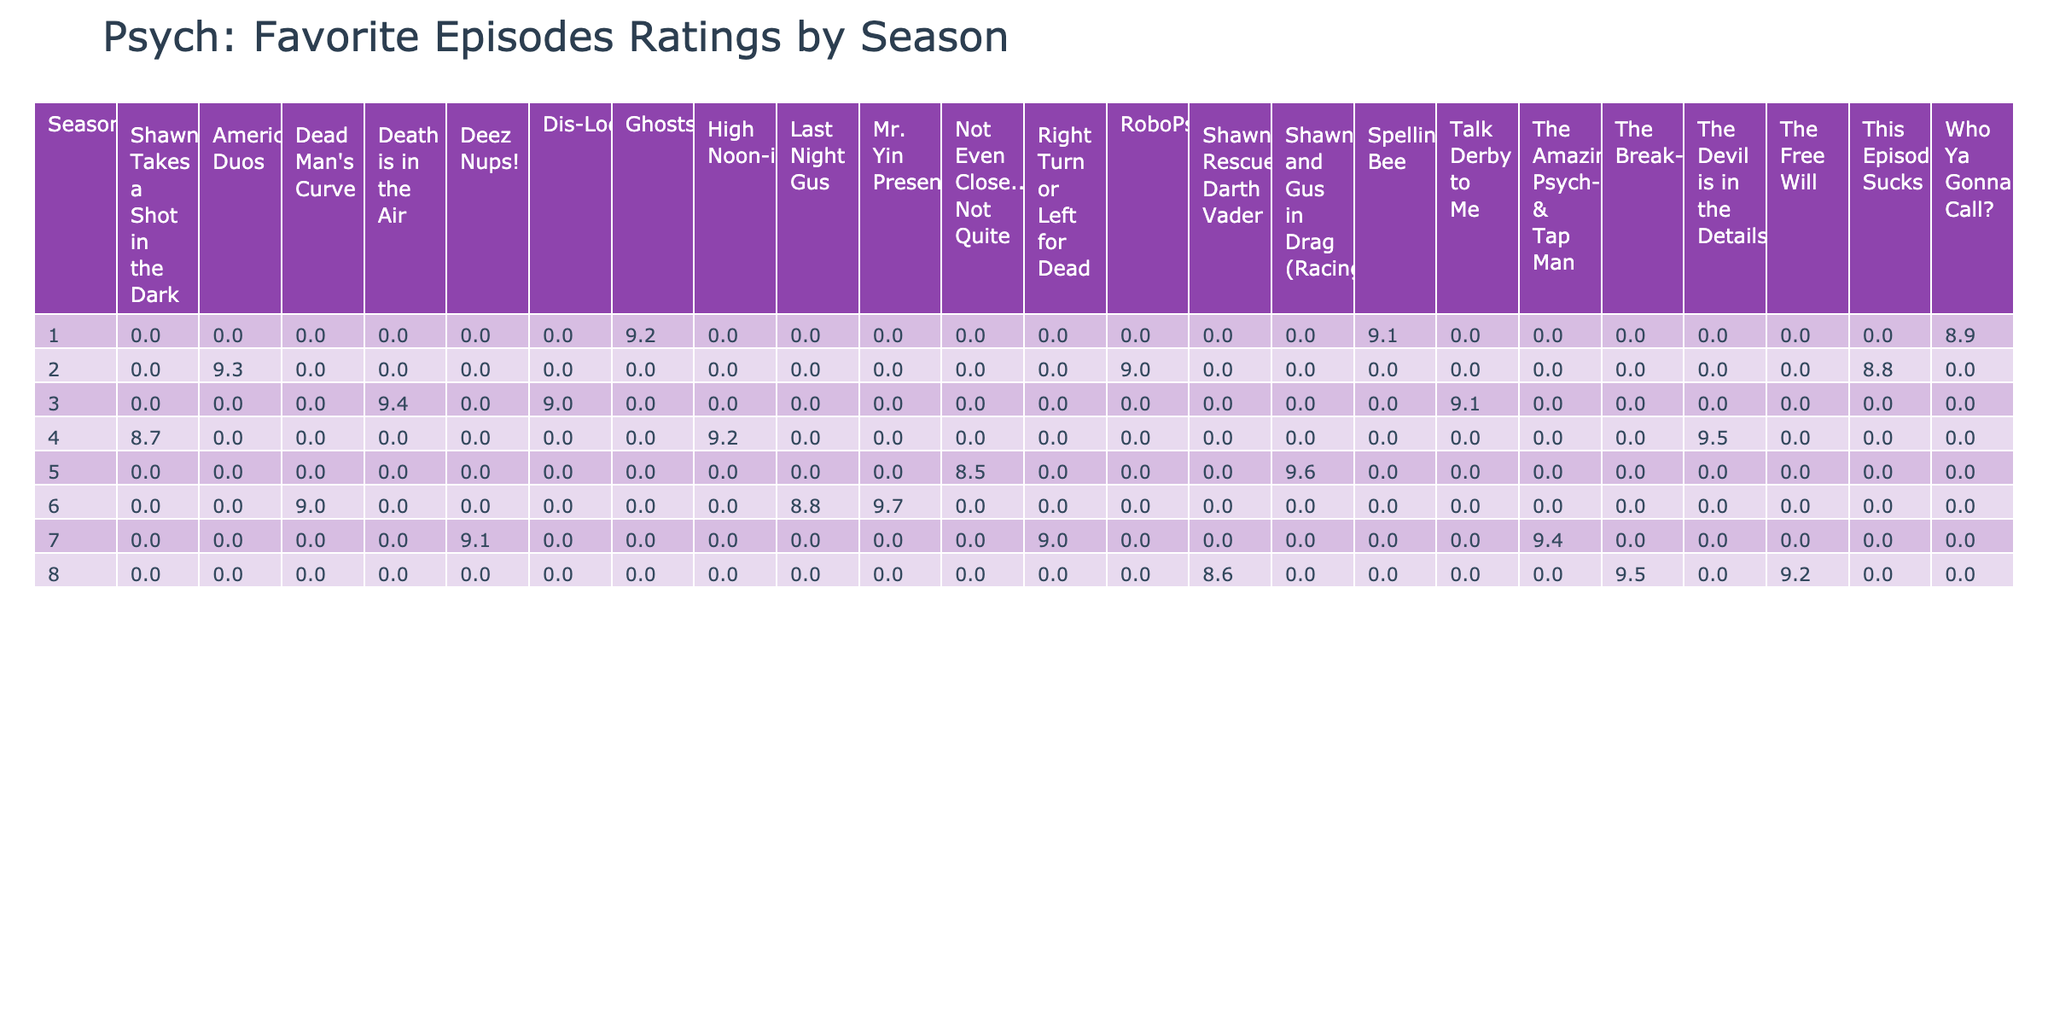What is the highest rating episode in Season 4? According to the table, the episodes in Season 4 are "The Devil is in the Details" (9.5), "High Noon-ish" (9.2), and "Shawn Takes a Shot in the Dark" (8.7). The highest rating among these is 9.5 for "The Devil is in the Details."
Answer: 9.5 Which episode in Season 5 has the lowest rating? The episodes in Season 5 are "Shawn and Gus in Drag (Racing)" (9.6) and "Not Even Close...But Not Quite" (8.5). Comparing these ratings, "Not Even Close...But Not Quite" has the lowest rating of 8.5.
Answer: 8.5 What is the average rating for all episodes in Season 3? The episodes in Season 3 are "Death is in the Air" (9.4), "Talk Derby to Me" (9.1), and "Dis-Lodged" (9.0). To find the average, we sum the ratings: 9.4 + 9.1 + 9.0 = 27.5. Then, we divide by 3 (the number of episodes), resulting in an average of 27.5 / 3 = 9.17.
Answer: 9.17 Is there any episode in Season 6 with a rating of 9.0 or higher? The episodes in Season 6 are "Mr. Yin Presents..." (9.7), "Dead Man's Curve" (9.0), and "Last Night Gus" (8.8). Both "Mr. Yin Presents..." and "Dead Man's Curve" have ratings of 9.0 or higher, so the answer is yes.
Answer: Yes What is the difference in rating between the highest-rated episode in Season 7 and the lowest-rated episode in Season 1? The highest-rated episode in Season 7 is "The Amazing Psych-Man & Tap Man" (9.4), and the lowest-rated episode in Season 1 is "Who Ya Gonna Call?" (8.9). To find the difference, subtract the lowest from the highest: 9.4 - 8.9 = 0.5.
Answer: 0.5 